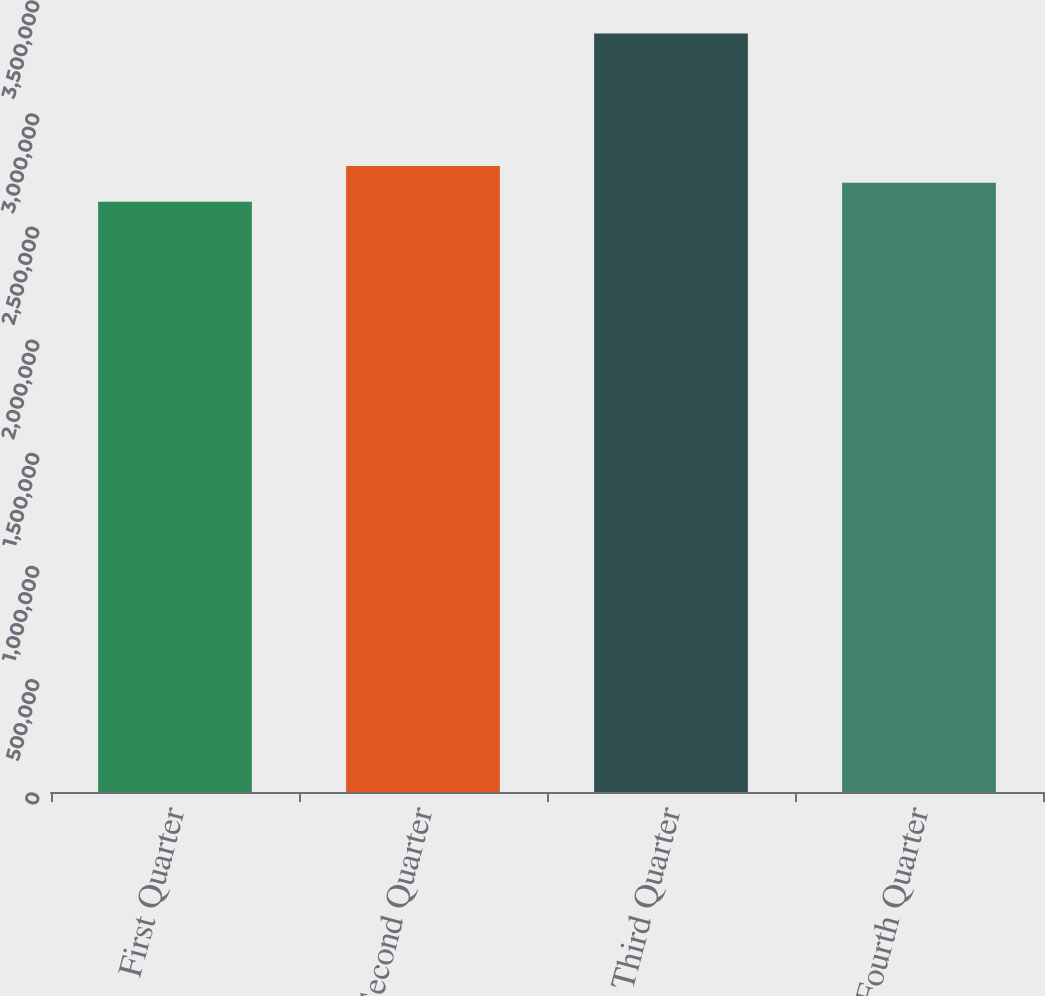Convert chart to OTSL. <chart><loc_0><loc_0><loc_500><loc_500><bar_chart><fcel>First Quarter<fcel>Second Quarter<fcel>Third Quarter<fcel>Fourth Quarter<nl><fcel>2.60887e+06<fcel>2.76621e+06<fcel>3.35196e+06<fcel>2.69191e+06<nl></chart> 